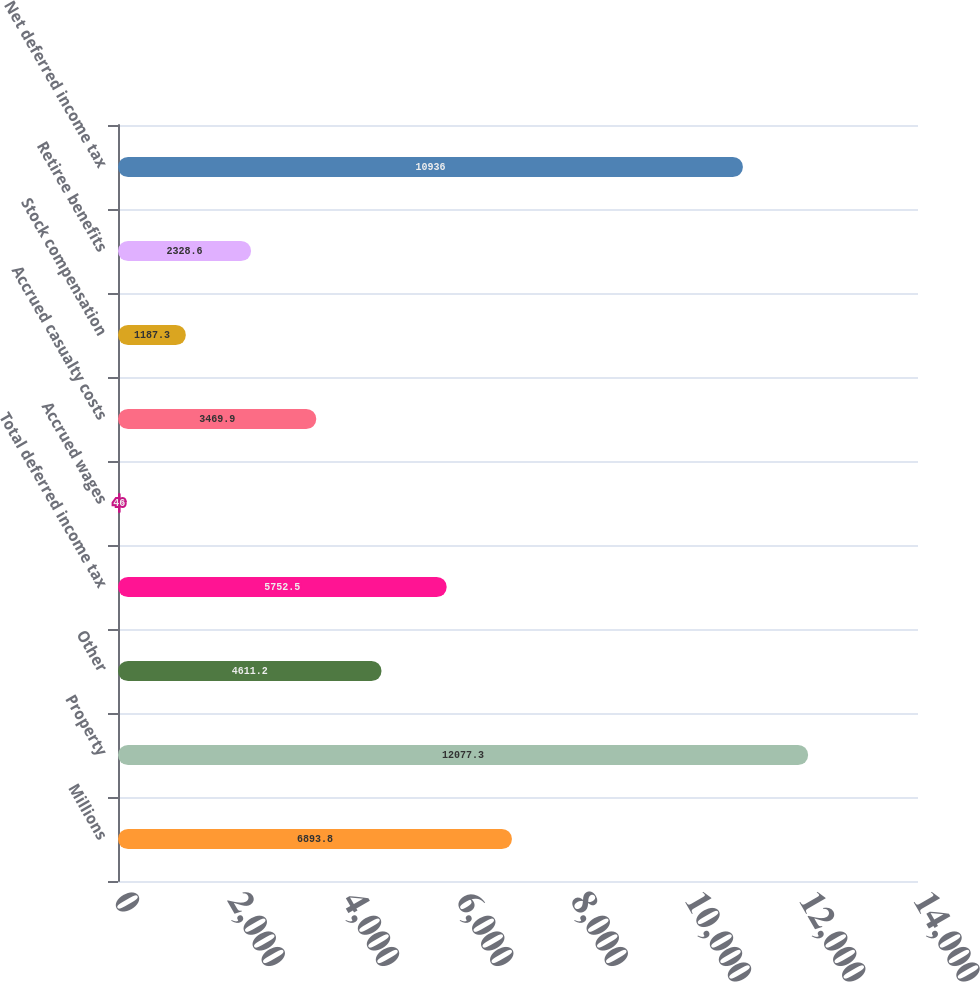Convert chart. <chart><loc_0><loc_0><loc_500><loc_500><bar_chart><fcel>Millions<fcel>Property<fcel>Other<fcel>Total deferred income tax<fcel>Accrued wages<fcel>Accrued casualty costs<fcel>Stock compensation<fcel>Retiree benefits<fcel>Net deferred income tax<nl><fcel>6893.8<fcel>12077.3<fcel>4611.2<fcel>5752.5<fcel>46<fcel>3469.9<fcel>1187.3<fcel>2328.6<fcel>10936<nl></chart> 